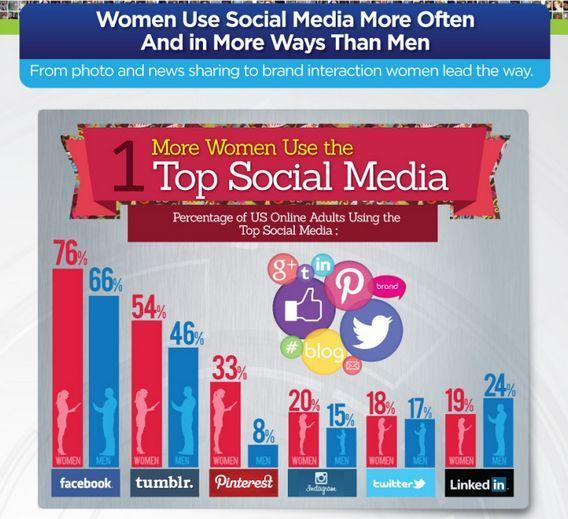Which social media tool is the least used by men, Twitter, Instagram, or Pinterest?
Answer the question with a short phrase. Pinterest Which is the second least used  social media tool by women? LinkedIn 